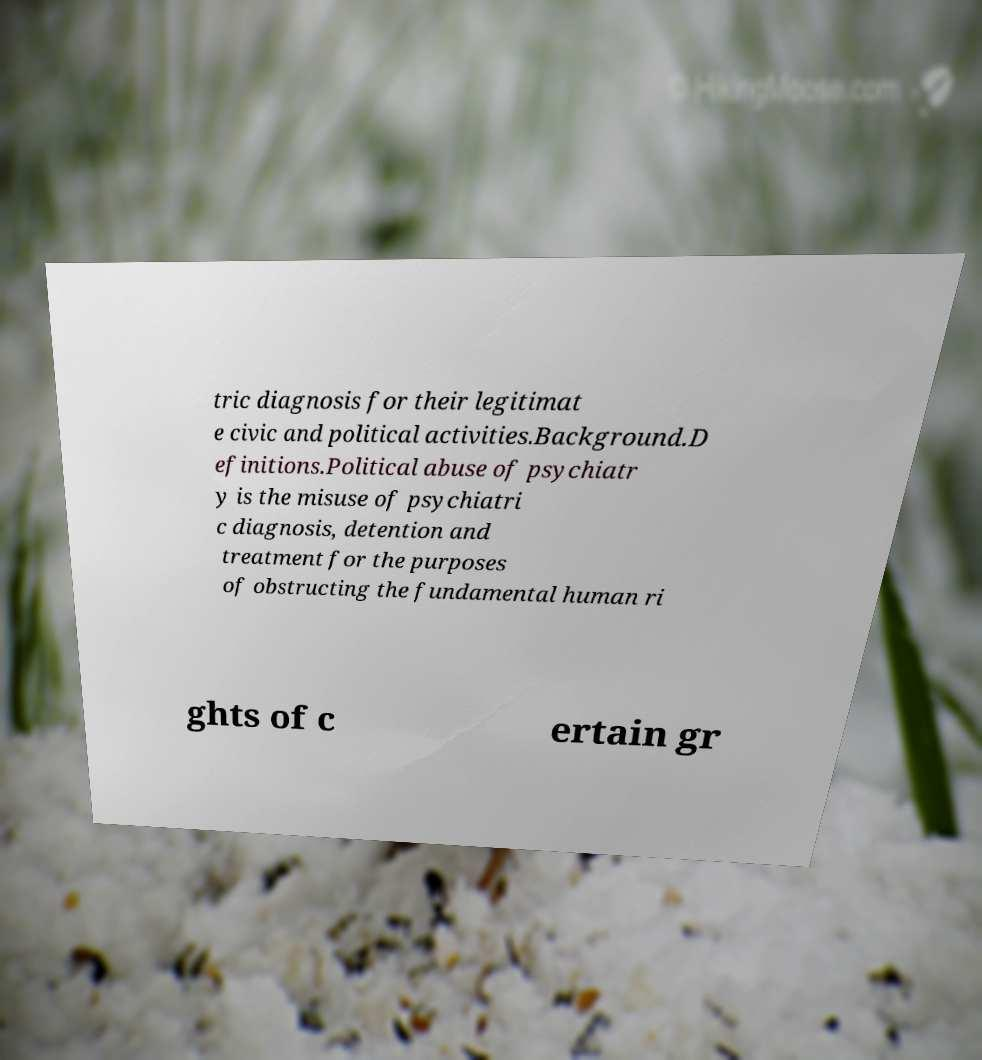I need the written content from this picture converted into text. Can you do that? tric diagnosis for their legitimat e civic and political activities.Background.D efinitions.Political abuse of psychiatr y is the misuse of psychiatri c diagnosis, detention and treatment for the purposes of obstructing the fundamental human ri ghts of c ertain gr 